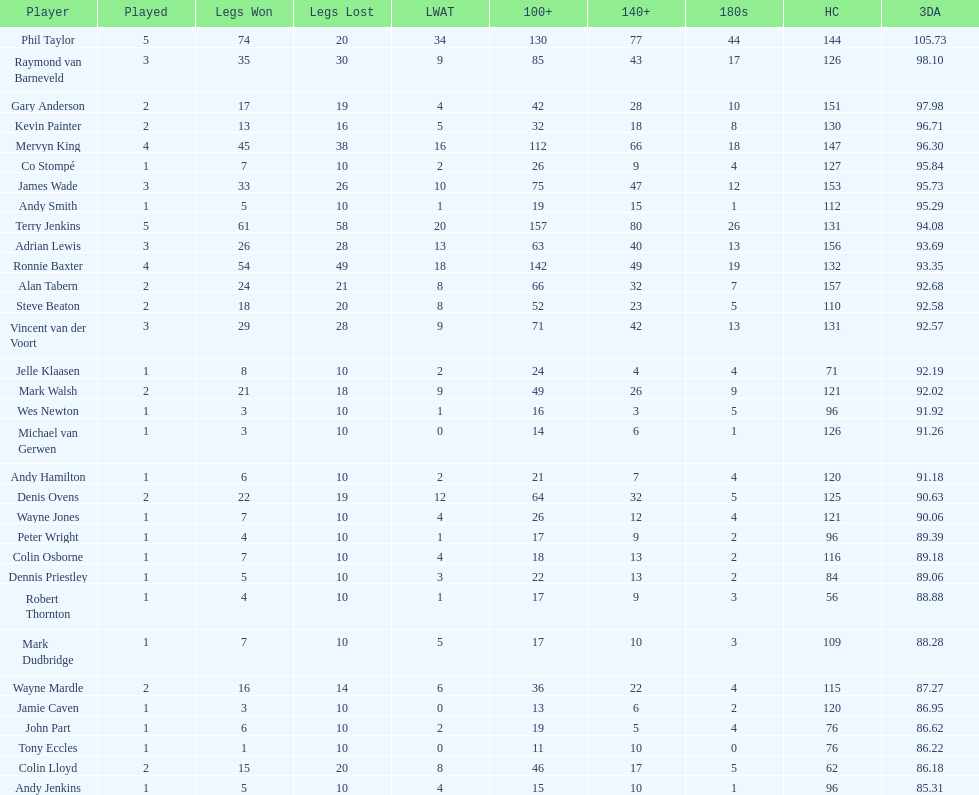Can you name all the players who have achieved a high checkout of 131? Terry Jenkins, Vincent van der Voort. 